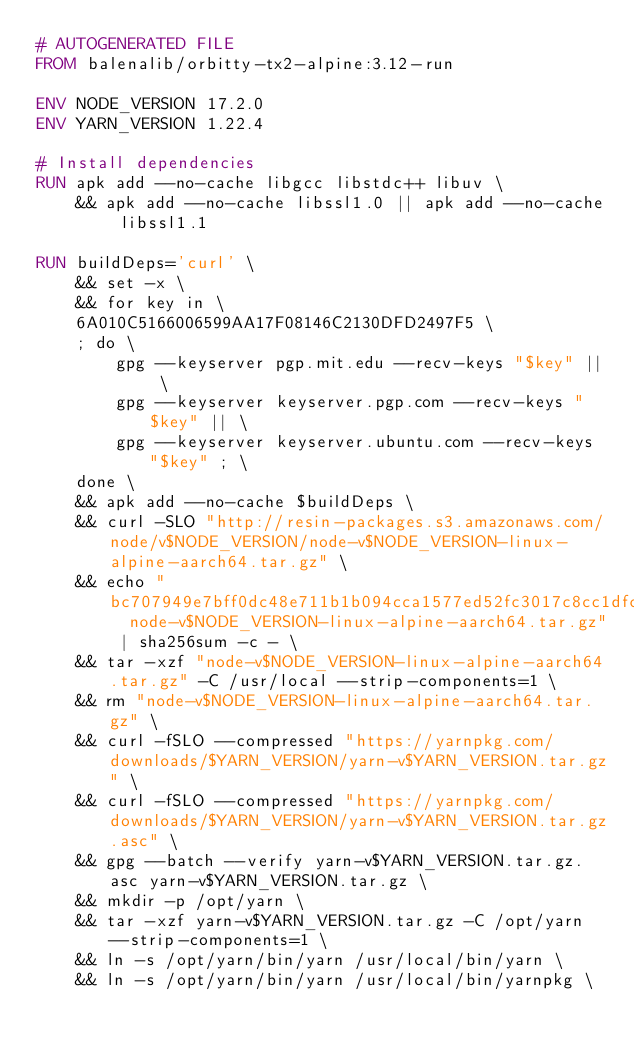Convert code to text. <code><loc_0><loc_0><loc_500><loc_500><_Dockerfile_># AUTOGENERATED FILE
FROM balenalib/orbitty-tx2-alpine:3.12-run

ENV NODE_VERSION 17.2.0
ENV YARN_VERSION 1.22.4

# Install dependencies
RUN apk add --no-cache libgcc libstdc++ libuv \
	&& apk add --no-cache libssl1.0 || apk add --no-cache libssl1.1

RUN buildDeps='curl' \
	&& set -x \
	&& for key in \
	6A010C5166006599AA17F08146C2130DFD2497F5 \
	; do \
		gpg --keyserver pgp.mit.edu --recv-keys "$key" || \
		gpg --keyserver keyserver.pgp.com --recv-keys "$key" || \
		gpg --keyserver keyserver.ubuntu.com --recv-keys "$key" ; \
	done \
	&& apk add --no-cache $buildDeps \
	&& curl -SLO "http://resin-packages.s3.amazonaws.com/node/v$NODE_VERSION/node-v$NODE_VERSION-linux-alpine-aarch64.tar.gz" \
	&& echo "bc707949e7bff0dc48e711b1b094cca1577ed52fc3017c8cc1dfc4b28f9dc77f  node-v$NODE_VERSION-linux-alpine-aarch64.tar.gz" | sha256sum -c - \
	&& tar -xzf "node-v$NODE_VERSION-linux-alpine-aarch64.tar.gz" -C /usr/local --strip-components=1 \
	&& rm "node-v$NODE_VERSION-linux-alpine-aarch64.tar.gz" \
	&& curl -fSLO --compressed "https://yarnpkg.com/downloads/$YARN_VERSION/yarn-v$YARN_VERSION.tar.gz" \
	&& curl -fSLO --compressed "https://yarnpkg.com/downloads/$YARN_VERSION/yarn-v$YARN_VERSION.tar.gz.asc" \
	&& gpg --batch --verify yarn-v$YARN_VERSION.tar.gz.asc yarn-v$YARN_VERSION.tar.gz \
	&& mkdir -p /opt/yarn \
	&& tar -xzf yarn-v$YARN_VERSION.tar.gz -C /opt/yarn --strip-components=1 \
	&& ln -s /opt/yarn/bin/yarn /usr/local/bin/yarn \
	&& ln -s /opt/yarn/bin/yarn /usr/local/bin/yarnpkg \</code> 